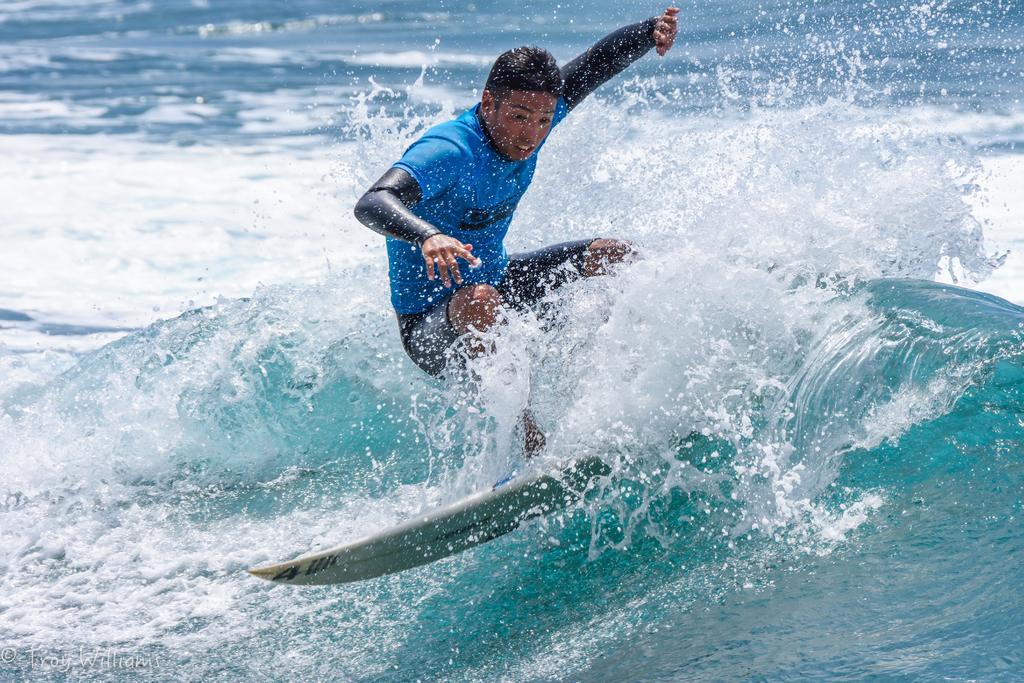Describe this image in one or two sentences. In this image we can see a person surfing in the water and we can see the waves. 